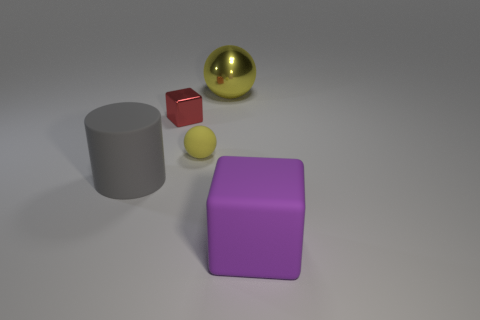Add 3 red cubes. How many objects exist? 8 Subtract all balls. How many objects are left? 3 Subtract 0 brown cubes. How many objects are left? 5 Subtract all big cyan things. Subtract all gray cylinders. How many objects are left? 4 Add 4 big metal things. How many big metal things are left? 5 Add 5 large cyan matte balls. How many large cyan matte balls exist? 5 